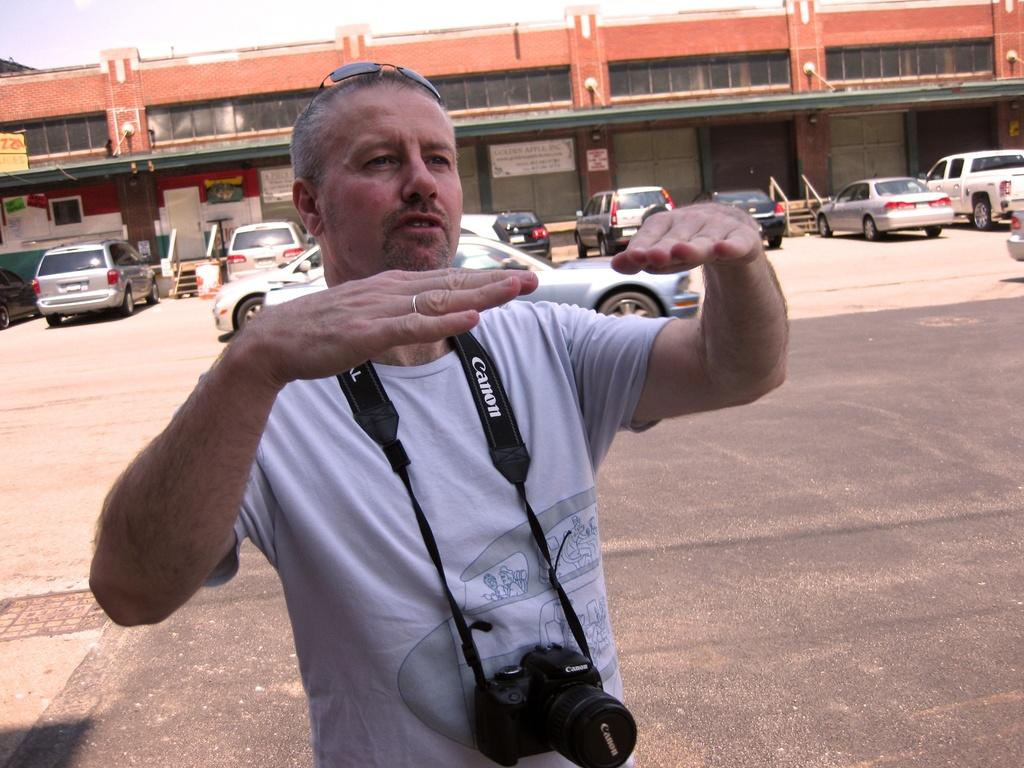What is the man in the image doing? The man is standing and talking. What can be seen in the background of the image? There are cars, a building, boards, a table, and the sky visible in the background of the image. What type of quill is the man using to write on the boards in the image? There is no quill present in the image, and the man is standing and talking, not writing on any boards. 